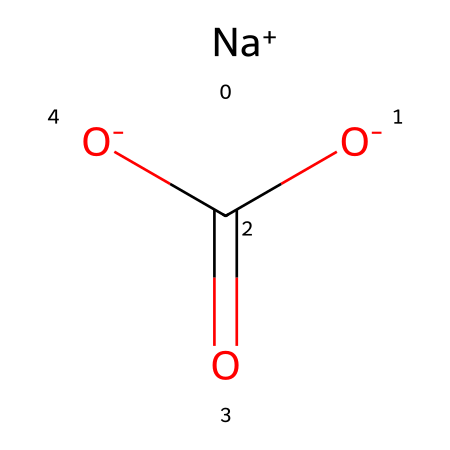how many oxygen atoms are in sodium bicarbonate? The structure contains two negatively charged oxygen atoms associated with the carboxylate and one oxygen atom double-bonded to carbon, totaling three oxygen atoms.
Answer: three what is the charge of sodium in sodium bicarbonate? In the structure, sodium is indicated as [Na+], showing it has a positive charge.
Answer: positive what type of compound is sodium bicarbonate? Sodium bicarbonate is categorized as a salt formed from the neutralization of an acid (carbonic acid) and a base (sodium hydroxide).
Answer: salt how many hydrogen atoms are present in sodium bicarbonate? The structure shows that there are two hydrogen atoms present, both associated with the carboxylate group.
Answer: two what does the presence of the bicarbonate ion indicate about its pH? The bicarbonate ion acts as a buffering agent, helping to maintain a slightly alkaline pH in solution, around 7-8.
Answer: slightly alkaline is sodium bicarbonate a hypervalent compound? The molecule does not have any central atom with expanded valence beyond the octet rule; thus, it is not classified as hypervalent.
Answer: no 